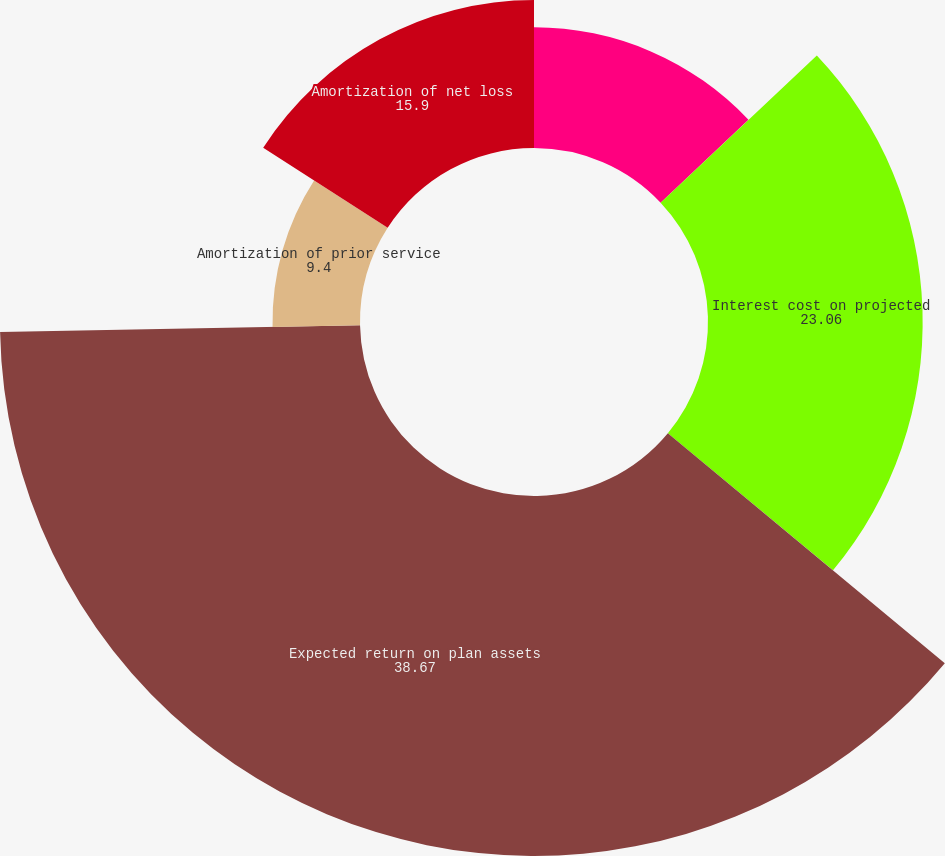Convert chart to OTSL. <chart><loc_0><loc_0><loc_500><loc_500><pie_chart><fcel>Service cost - benefits earned<fcel>Interest cost on projected<fcel>Expected return on plan assets<fcel>Amortization of prior service<fcel>Amortization of net loss<nl><fcel>12.97%<fcel>23.06%<fcel>38.67%<fcel>9.4%<fcel>15.9%<nl></chart> 